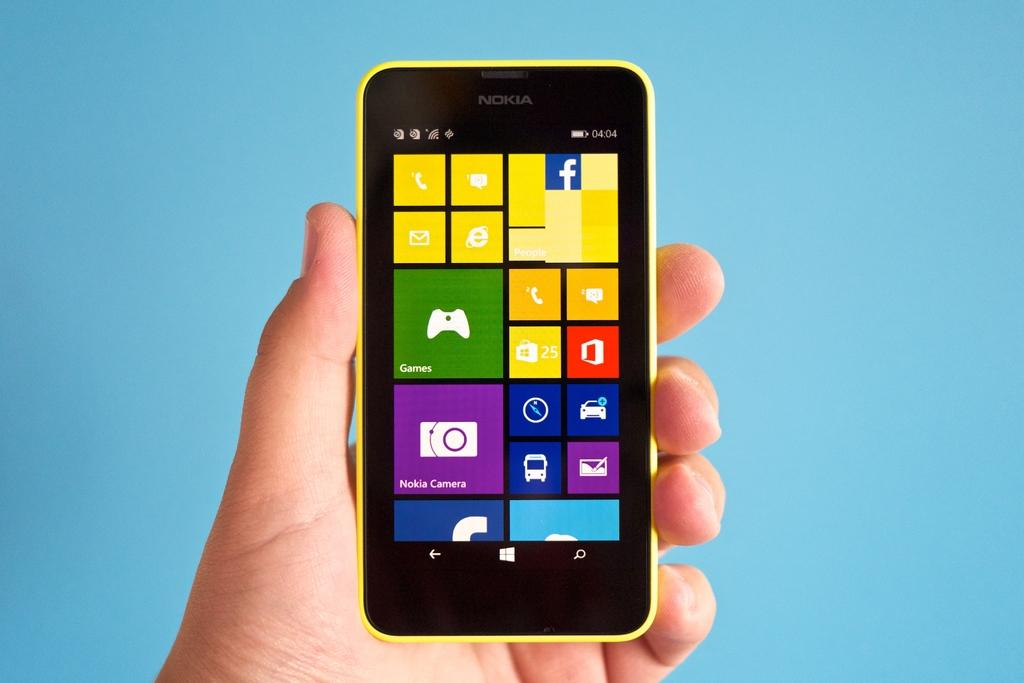<image>
Relay a brief, clear account of the picture shown. A Nokia smart phone open to the Windows homepage. 